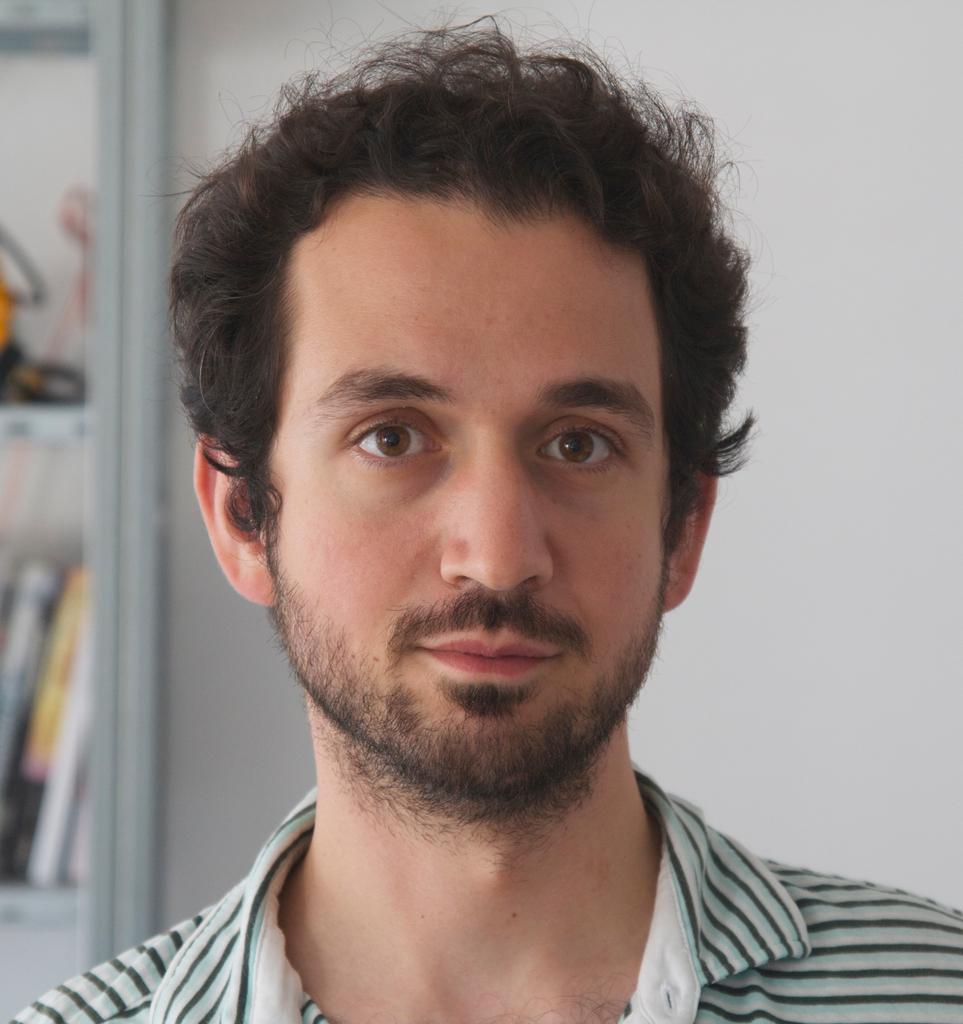Please provide a concise description of this image. In this image we can see a man. In the background we can see wall, books, and few objects on the racks. 